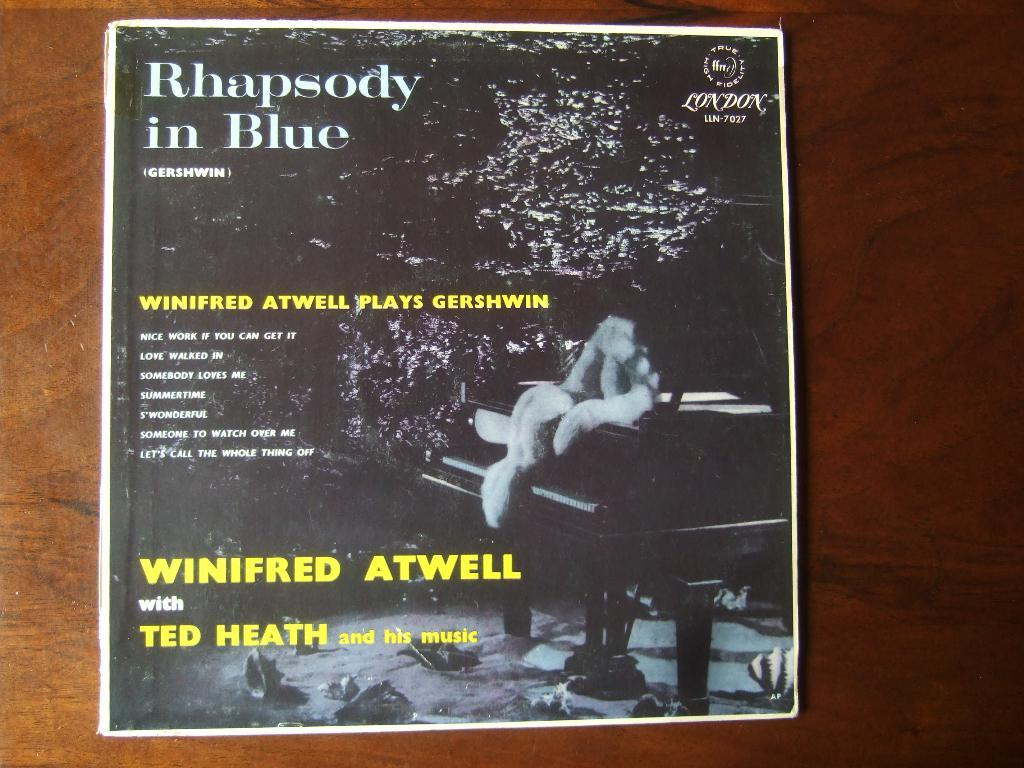<image>
Create a compact narrative representing the image presented. Album poster titled Rhapsody in Blue showing a piano in the front. 